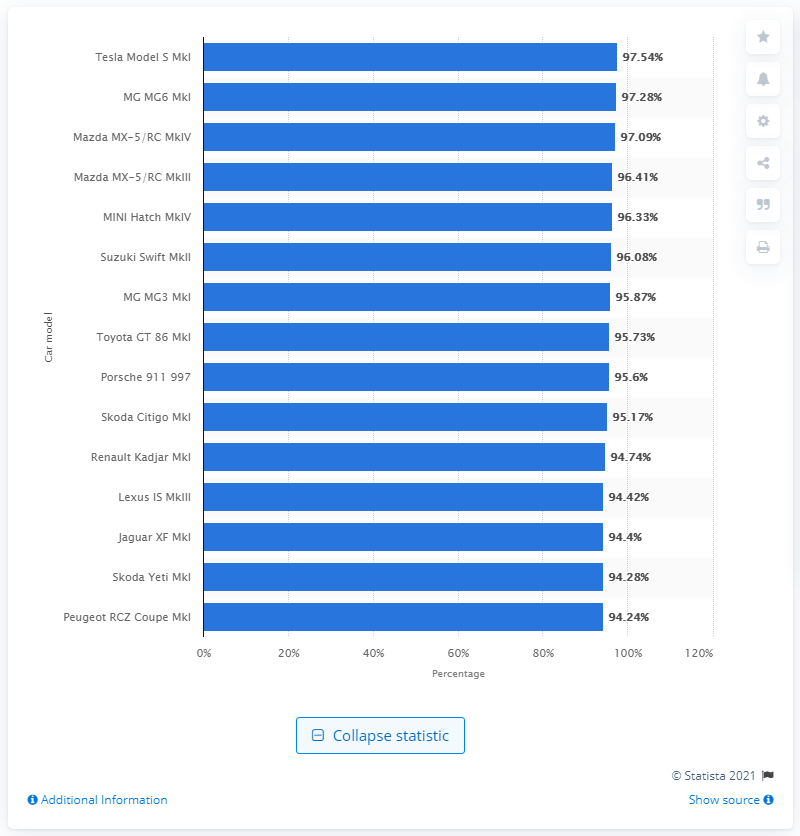Specify some key components in this picture. The Tesla Model S MkI performed the best in the road handling category. 